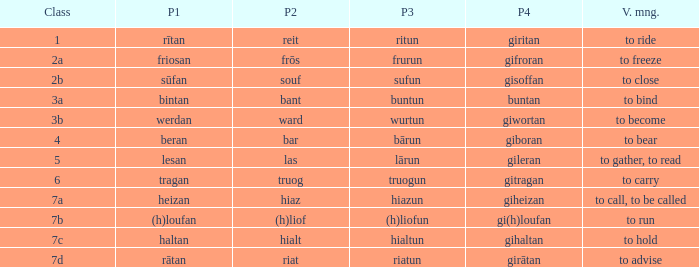What is the verb meaning of the word with part 2 "bant"? To bind. Can you give me this table as a dict? {'header': ['Class', 'P1', 'P2', 'P3', 'P4', 'V. mng.'], 'rows': [['1', 'rītan', 'reit', 'ritun', 'giritan', 'to ride'], ['2a', 'friosan', 'frōs', 'frurun', 'gifroran', 'to freeze'], ['2b', 'sūfan', 'souf', 'sufun', 'gisoffan', 'to close'], ['3a', 'bintan', 'bant', 'buntun', 'buntan', 'to bind'], ['3b', 'werdan', 'ward', 'wurtun', 'giwortan', 'to become'], ['4', 'beran', 'bar', 'bārun', 'giboran', 'to bear'], ['5', 'lesan', 'las', 'lārun', 'gileran', 'to gather, to read'], ['6', 'tragan', 'truog', 'truogun', 'gitragan', 'to carry'], ['7a', 'heizan', 'hiaz', 'hiazun', 'giheizan', 'to call, to be called'], ['7b', '(h)loufan', '(h)liof', '(h)liofun', 'gi(h)loufan', 'to run'], ['7c', 'haltan', 'hialt', 'hialtun', 'gihaltan', 'to hold'], ['7d', 'rātan', 'riat', 'riatun', 'girātan', 'to advise']]} 